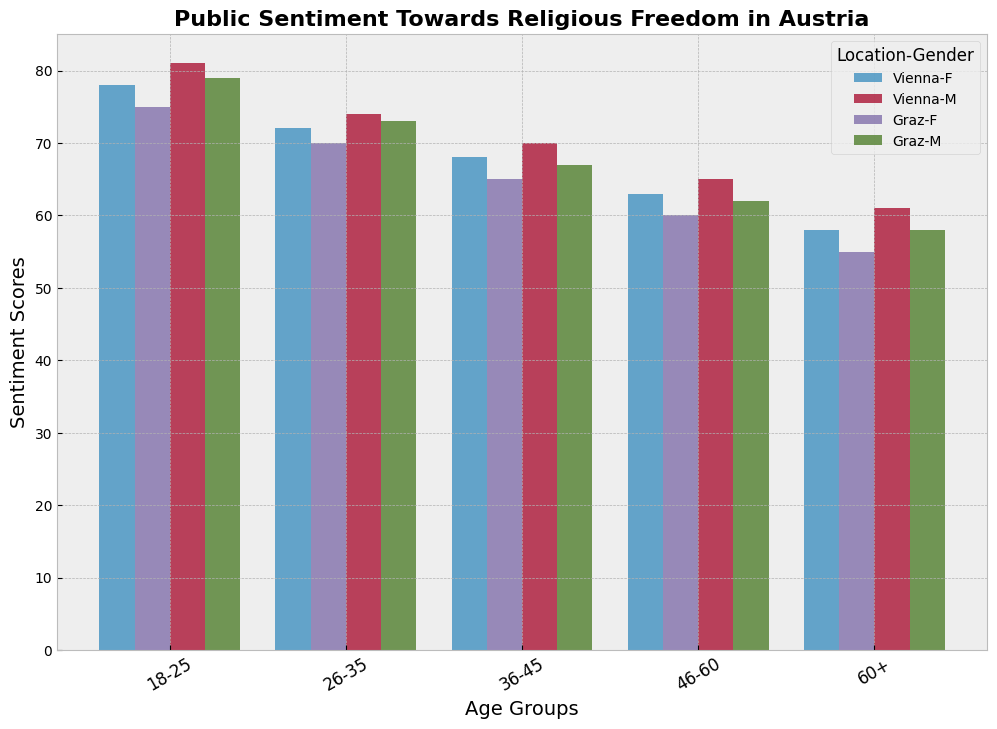What is the highest sentiment score among all demographic groups? Look for the tallest bar in the chart. It represents men aged 18-25 in Vienna with a score of 81.
Answer: 81 Which age group in Graz shows the lowest sentiment score? Compare all the bars for groups in Graz and identify the lowest one. Women aged 60+ in Graz have the lowest score at 55.
Answer: 55 How does the sentiment score for women aged 26-35 in Vienna compare to women aged 60+ in Vienna? Identify the bars for women aged 26-35 and 60+ in Vienna. For 26-35, the score is 72. For 60+, the score is 58. 72 is higher than 58.
Answer: Women aged 26-35 in Vienna have a higher score than women aged 60+ in Vienna What is the average sentiment score for men in Graz across all age groups? Find the bars for men in Graz and note their scores: 79 (18-25), 73 (26-35), 67 (36-45), 62 (46-60), and 58 (60+). Calculate the average, (79+73+67+62+58)/5 = 67.8.
Answer: 67.8 Which location-gender group has the most similar sentiment score to women aged 18-25 in Vienna? Identify the bar for women aged 18-25 in Vienna (78) and look for another bar close to this score. The closest is men aged 18-25 in Graz with a score of 79.
Answer: Men aged 18-25 in Graz Between men and women in Vienna aged 36-45, who has a higher sentiment score? Compare the bars for men and women aged 36-45 in Vienna. Men have a score of 70, and women have 68.
Answer: Men aged 36-45 in Vienna What's the difference in sentiment scores between women aged 18-25 and women aged 60+ in Graz? Find the scores for women aged 18-25 (75) and women aged 60+ (55) in Graz. Subtract 55 from 75.
Answer: 20 How do sentiment scores for the 46-60 age group compare between Graz and Vienna? Look at the bars for the 46-60 age group in Graz and Vienna. Compare the bars: Graz has 60 and 62, Vienna has 63 and 65. Vienna has higher scores.
Answer: Vienna has higher scores for the 46-60 age group Which age group has the most significant decrease in sentiment score from the youngest to oldest age groups in Vienna? Follow the bars for each age group in Vienna, from 18-25 to 60+. The scores for women: 78 (18-25), 72 (26-35), 68 (36-45), 63 (46-60), 58 (60+). The biggest decline is 78 to 58, a decrease of 20.
Answer: Women (20) 